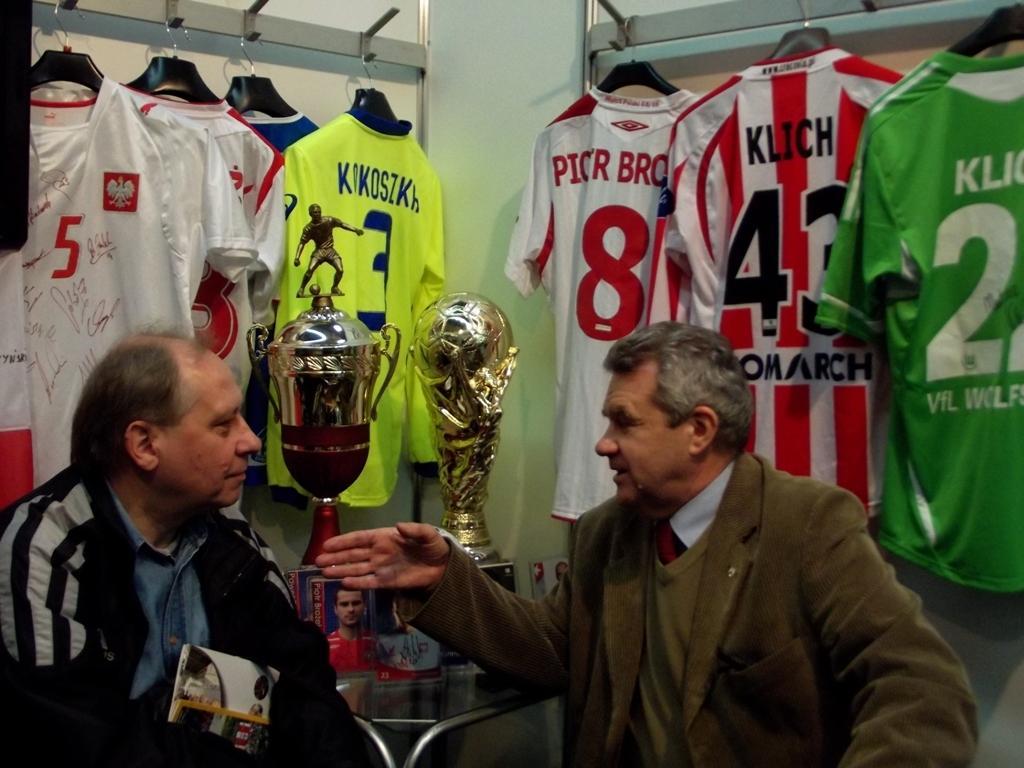<image>
Give a short and clear explanation of the subsequent image. Klich number 43 is on the back of the red and white striped jersey hanging on the wall. 